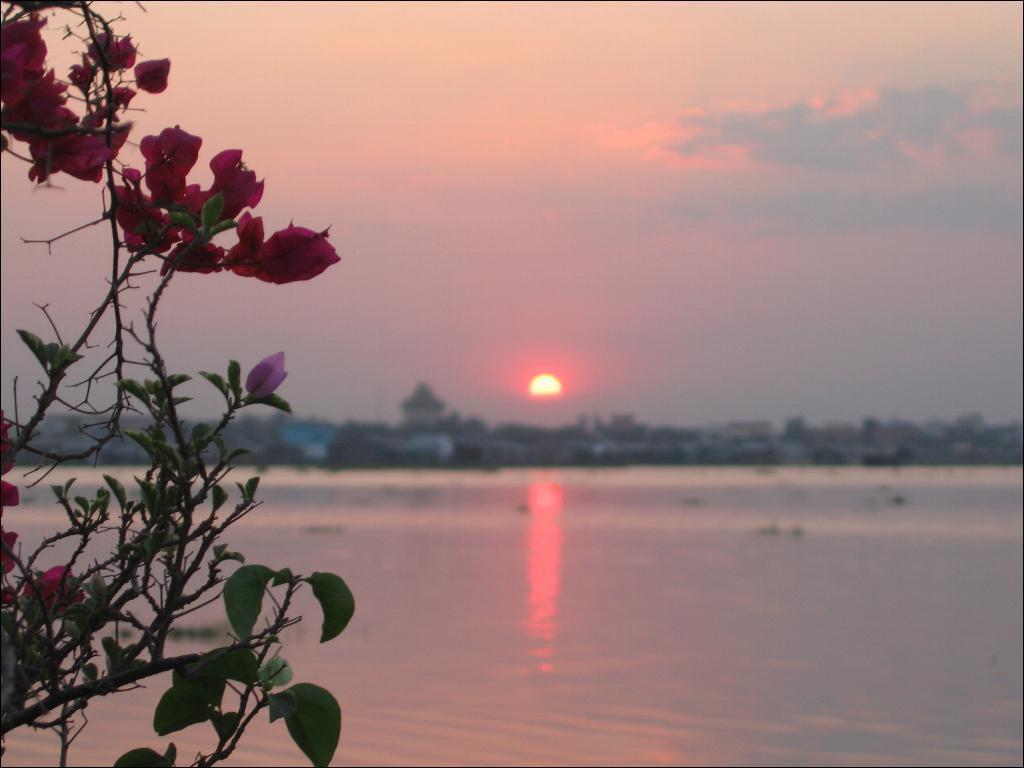Can you describe this image briefly? In this image there is a water surface, in the background there are buildings and the sky in that sky there is sun, on the left side there are flower plants. 